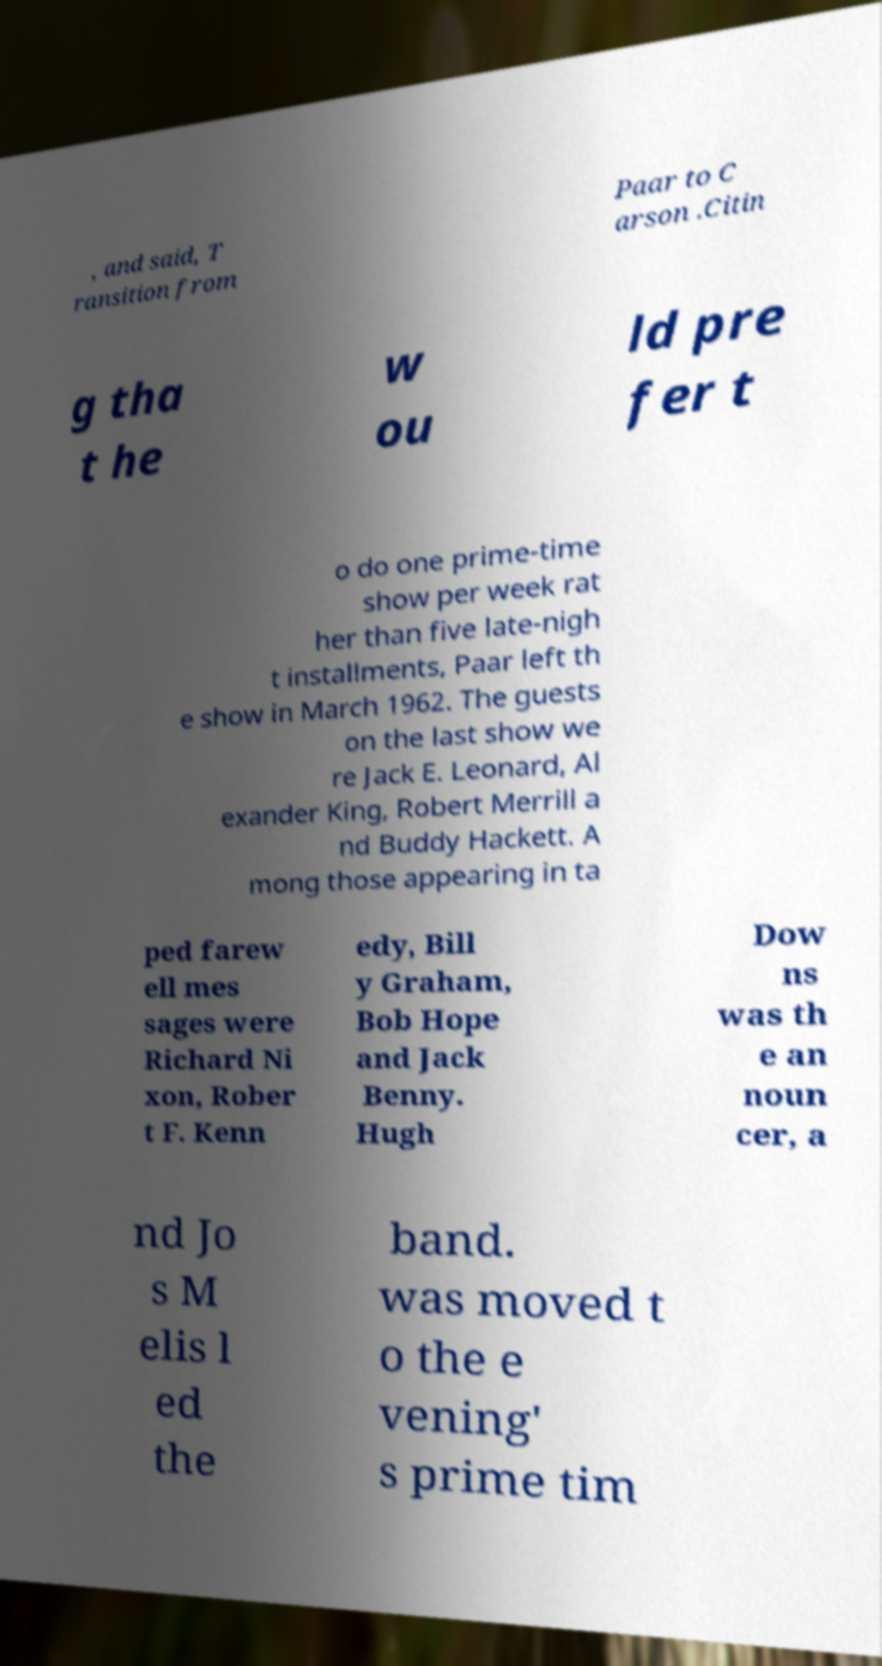Please read and relay the text visible in this image. What does it say? , and said, T ransition from Paar to C arson .Citin g tha t he w ou ld pre fer t o do one prime-time show per week rat her than five late-nigh t installments, Paar left th e show in March 1962. The guests on the last show we re Jack E. Leonard, Al exander King, Robert Merrill a nd Buddy Hackett. A mong those appearing in ta ped farew ell mes sages were Richard Ni xon, Rober t F. Kenn edy, Bill y Graham, Bob Hope and Jack Benny. Hugh Dow ns was th e an noun cer, a nd Jo s M elis l ed the band. was moved t o the e vening' s prime tim 